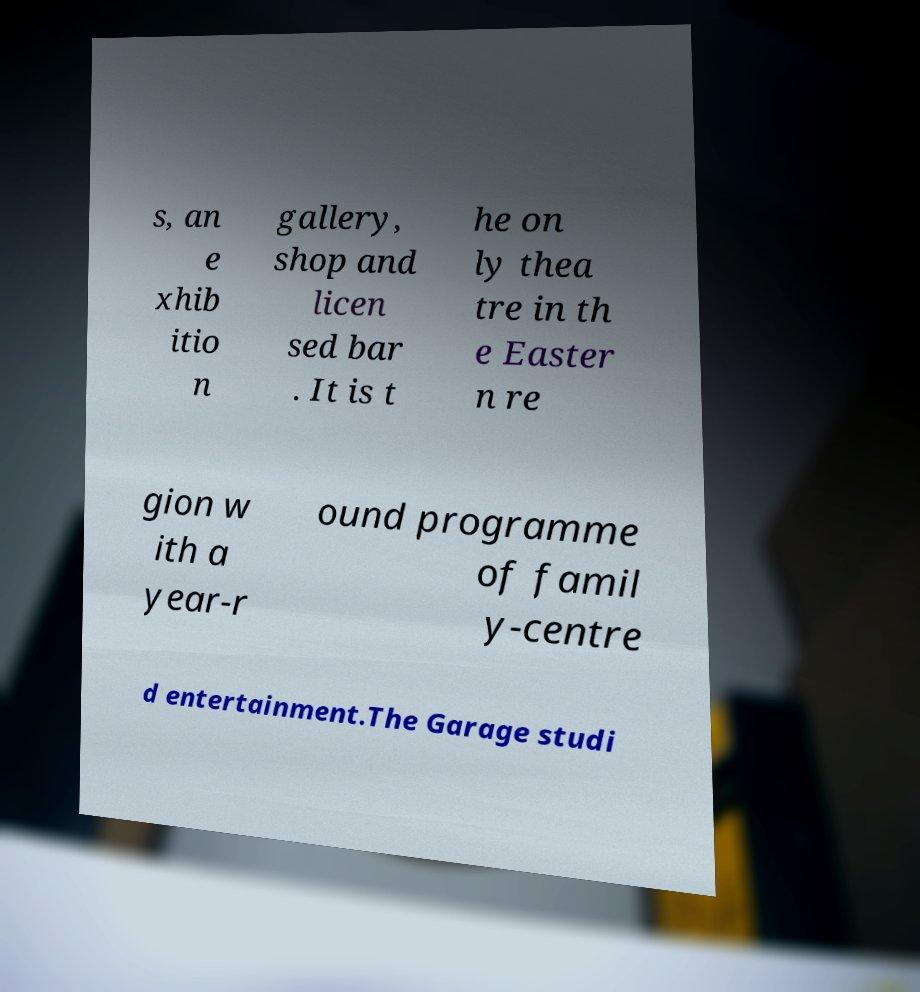I need the written content from this picture converted into text. Can you do that? s, an e xhib itio n gallery, shop and licen sed bar . It is t he on ly thea tre in th e Easter n re gion w ith a year-r ound programme of famil y-centre d entertainment.The Garage studi 